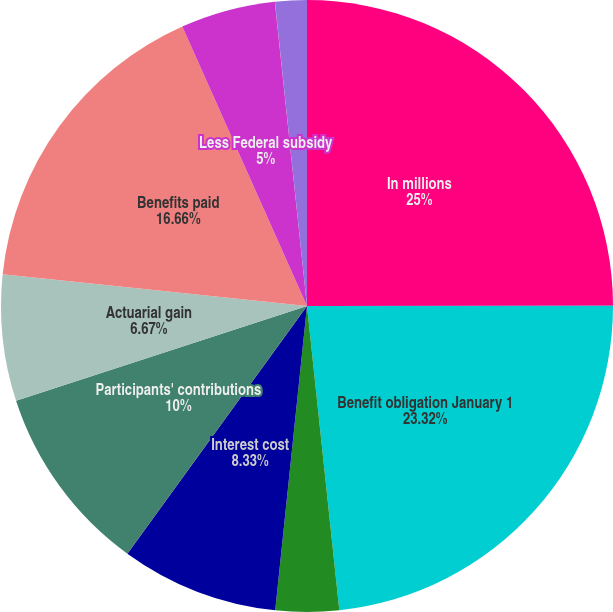Convert chart. <chart><loc_0><loc_0><loc_500><loc_500><pie_chart><fcel>In millions<fcel>Benefit obligation January 1<fcel>Service cost<fcel>Interest cost<fcel>Participants' contributions<fcel>Actuarial gain<fcel>Benefits paid<fcel>Less Federal subsidy<fcel>Curtailment<fcel>Special termination benefits<nl><fcel>24.99%<fcel>23.32%<fcel>3.34%<fcel>8.33%<fcel>10.0%<fcel>6.67%<fcel>16.66%<fcel>5.0%<fcel>0.01%<fcel>1.67%<nl></chart> 